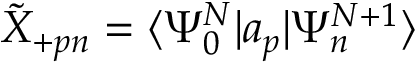<formula> <loc_0><loc_0><loc_500><loc_500>\tilde { X } _ { + p n } = \langle \Psi _ { 0 } ^ { N } | a _ { p } | \Psi _ { n } ^ { N + 1 } \rangle</formula> 